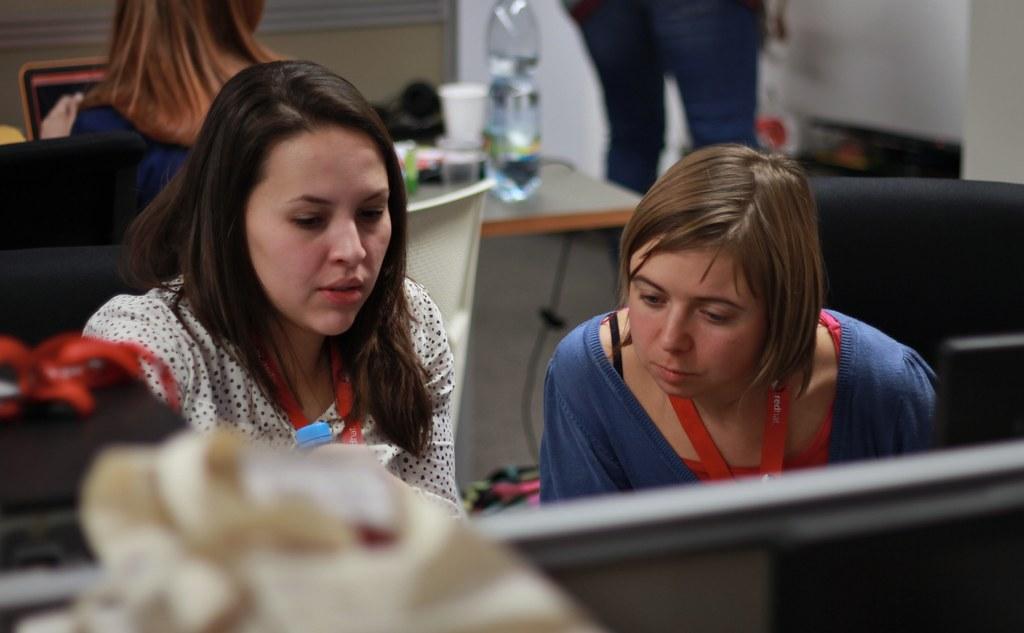Could you give a brief overview of what you see in this image? Here we can see two women are sitting on the chairs. There is a table. On the table there is a bottle, cup, and objects. In the background we can see two persons and wall. 